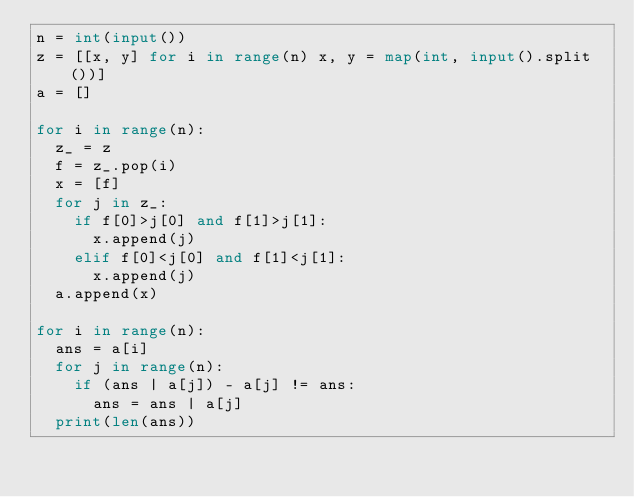Convert code to text. <code><loc_0><loc_0><loc_500><loc_500><_Python_>n = int(input())
z = [[x, y] for i in range(n) x, y = map(int, input().split())]
a = []

for i in range(n):
  z_ = z
  f = z_.pop(i)
  x = [f]
  for j in z_:
    if f[0]>j[0] and f[1]>j[1]:
      x.append(j)
    elif f[0]<j[0] and f[1]<j[1]:
      x.append(j)
  a.append(x)
  
for i in range(n):
  ans = a[i]
  for j in range(n):
    if (ans | a[j]) - a[j] != ans:
      ans = ans | a[j]
  print(len(ans))</code> 